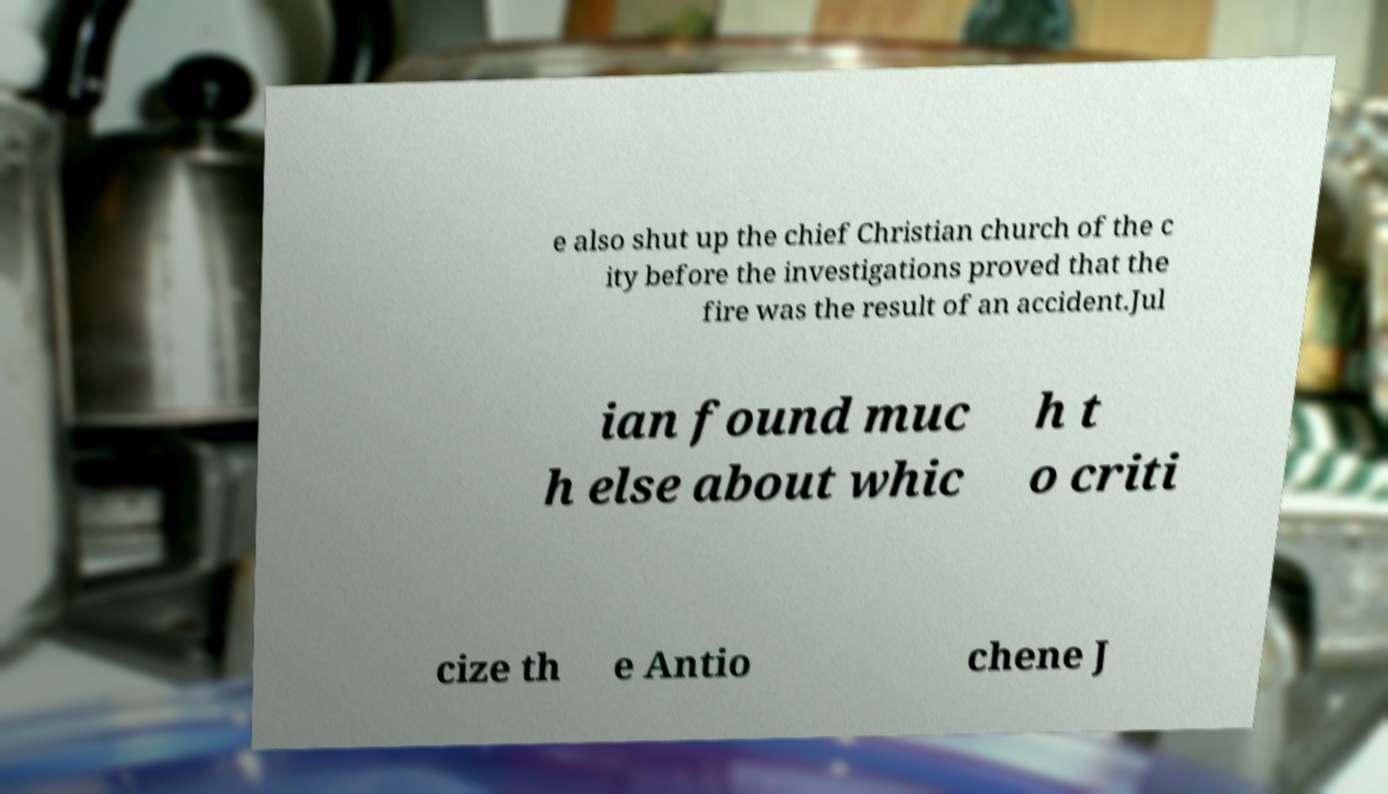Can you read and provide the text displayed in the image?This photo seems to have some interesting text. Can you extract and type it out for me? e also shut up the chief Christian church of the c ity before the investigations proved that the fire was the result of an accident.Jul ian found muc h else about whic h t o criti cize th e Antio chene J 